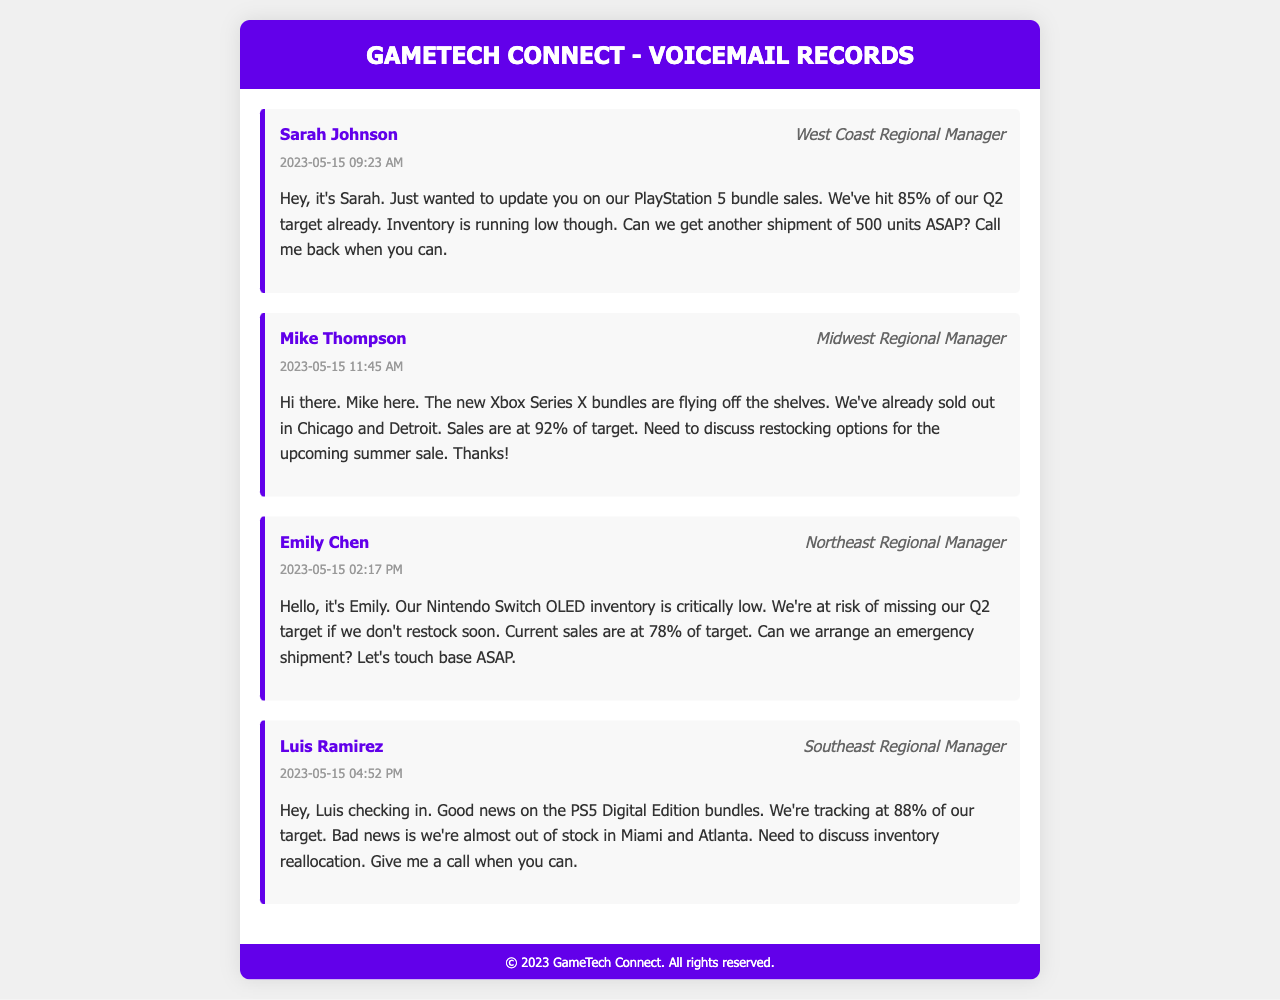What percentage of the Q2 sales target has Sarah's region achieved? Sarah reported that her region has hit 85% of the Q2 target.
Answer: 85% What is the main concern expressed by Emily? Emily mentioned that the Nintendo Switch OLED inventory is critically low, which could lead to missing the Q2 target.
Answer: Critically low inventory How many Xbox Series X bundles were sold of the target? Mike stated that sales are at 92% of the target for Xbox Series X bundles.
Answer: 92% Which regional manager mentioned discussing inventory reallocation? Luis, the Southeast Regional Manager, referred to discussing inventory reallocation due to low stock.
Answer: Luis Ramirez What is the desired quantity for the PS5 shipment requested by Sarah? Sarah requested another shipment of 500 units ASAP due to low inventory.
Answer: 500 units Which city did Mike mention being sold out of Xbox bundles? Mike indicated that Chicago is sold out of Xbox Series X bundles.
Answer: Chicago What is the timestamp of Emily's voicemail? The timestamp for Emily's voicemail is 02:17 PM on May 15, 2023.
Answer: 2023-05-15 02:17 PM What product is at risk of missing sales targets based on Emily's report? Emily's report indicates that the Nintendo Switch OLED is at risk of missing sales targets.
Answer: Nintendo Switch OLED How did Luis describe the sales performance of PS5 Digital Edition bundles? Luis mentioned tracking at 88% of their target for PS5 Digital Edition bundles.
Answer: 88% 